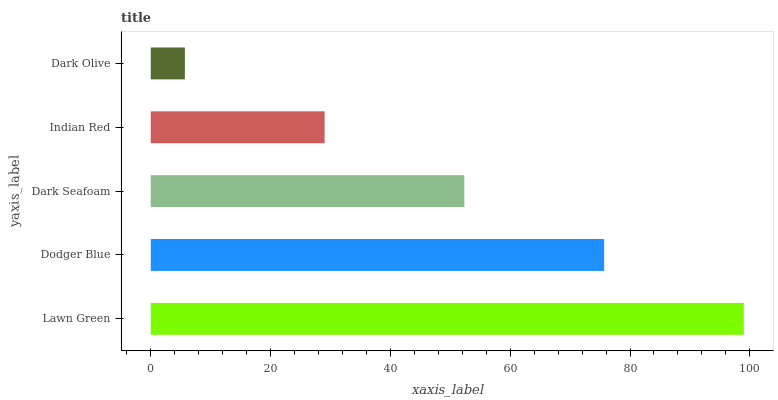Is Dark Olive the minimum?
Answer yes or no. Yes. Is Lawn Green the maximum?
Answer yes or no. Yes. Is Dodger Blue the minimum?
Answer yes or no. No. Is Dodger Blue the maximum?
Answer yes or no. No. Is Lawn Green greater than Dodger Blue?
Answer yes or no. Yes. Is Dodger Blue less than Lawn Green?
Answer yes or no. Yes. Is Dodger Blue greater than Lawn Green?
Answer yes or no. No. Is Lawn Green less than Dodger Blue?
Answer yes or no. No. Is Dark Seafoam the high median?
Answer yes or no. Yes. Is Dark Seafoam the low median?
Answer yes or no. Yes. Is Dodger Blue the high median?
Answer yes or no. No. Is Dodger Blue the low median?
Answer yes or no. No. 